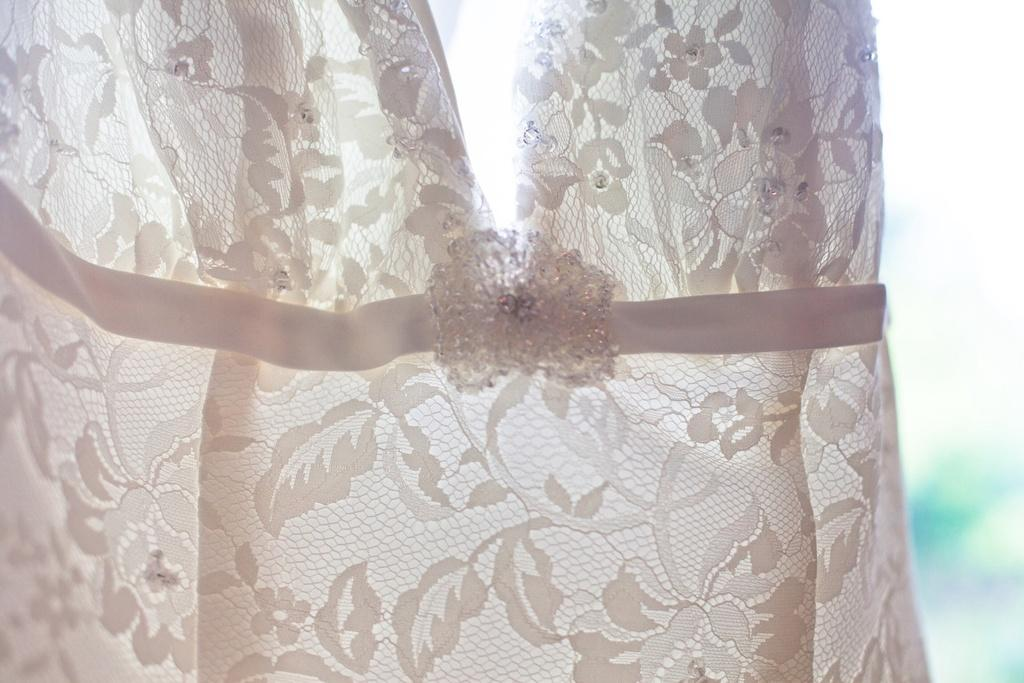What type of clothing is featured in the picture? There is a white dress in the picture. Can you describe the background in the image? The background behind the dress is blurred. What type of steel is used to make the nails in the picture? There are no nails or steel present in the image; it features a white dress with a blurred background. 